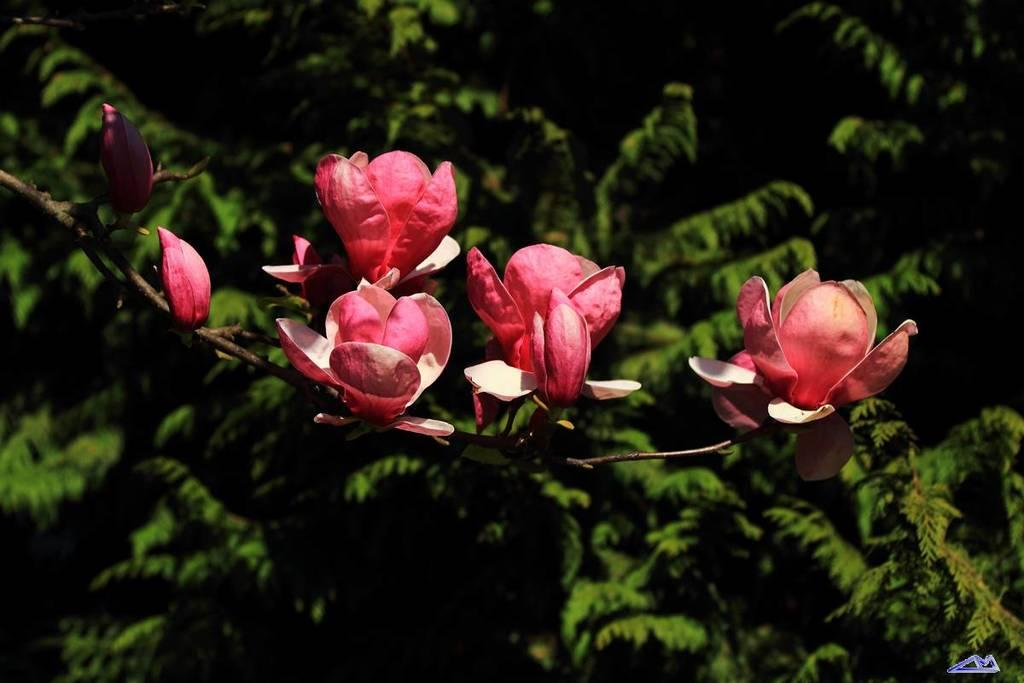What type of plants can be seen in the image? There are flowers in the image. What can be seen in the background of the image? There are trees in the background of the image. How many pets does the queen have in the image? There is no queen or pets present in the image. What type of animal is the zebra in the image? There is no zebra present in the image. 